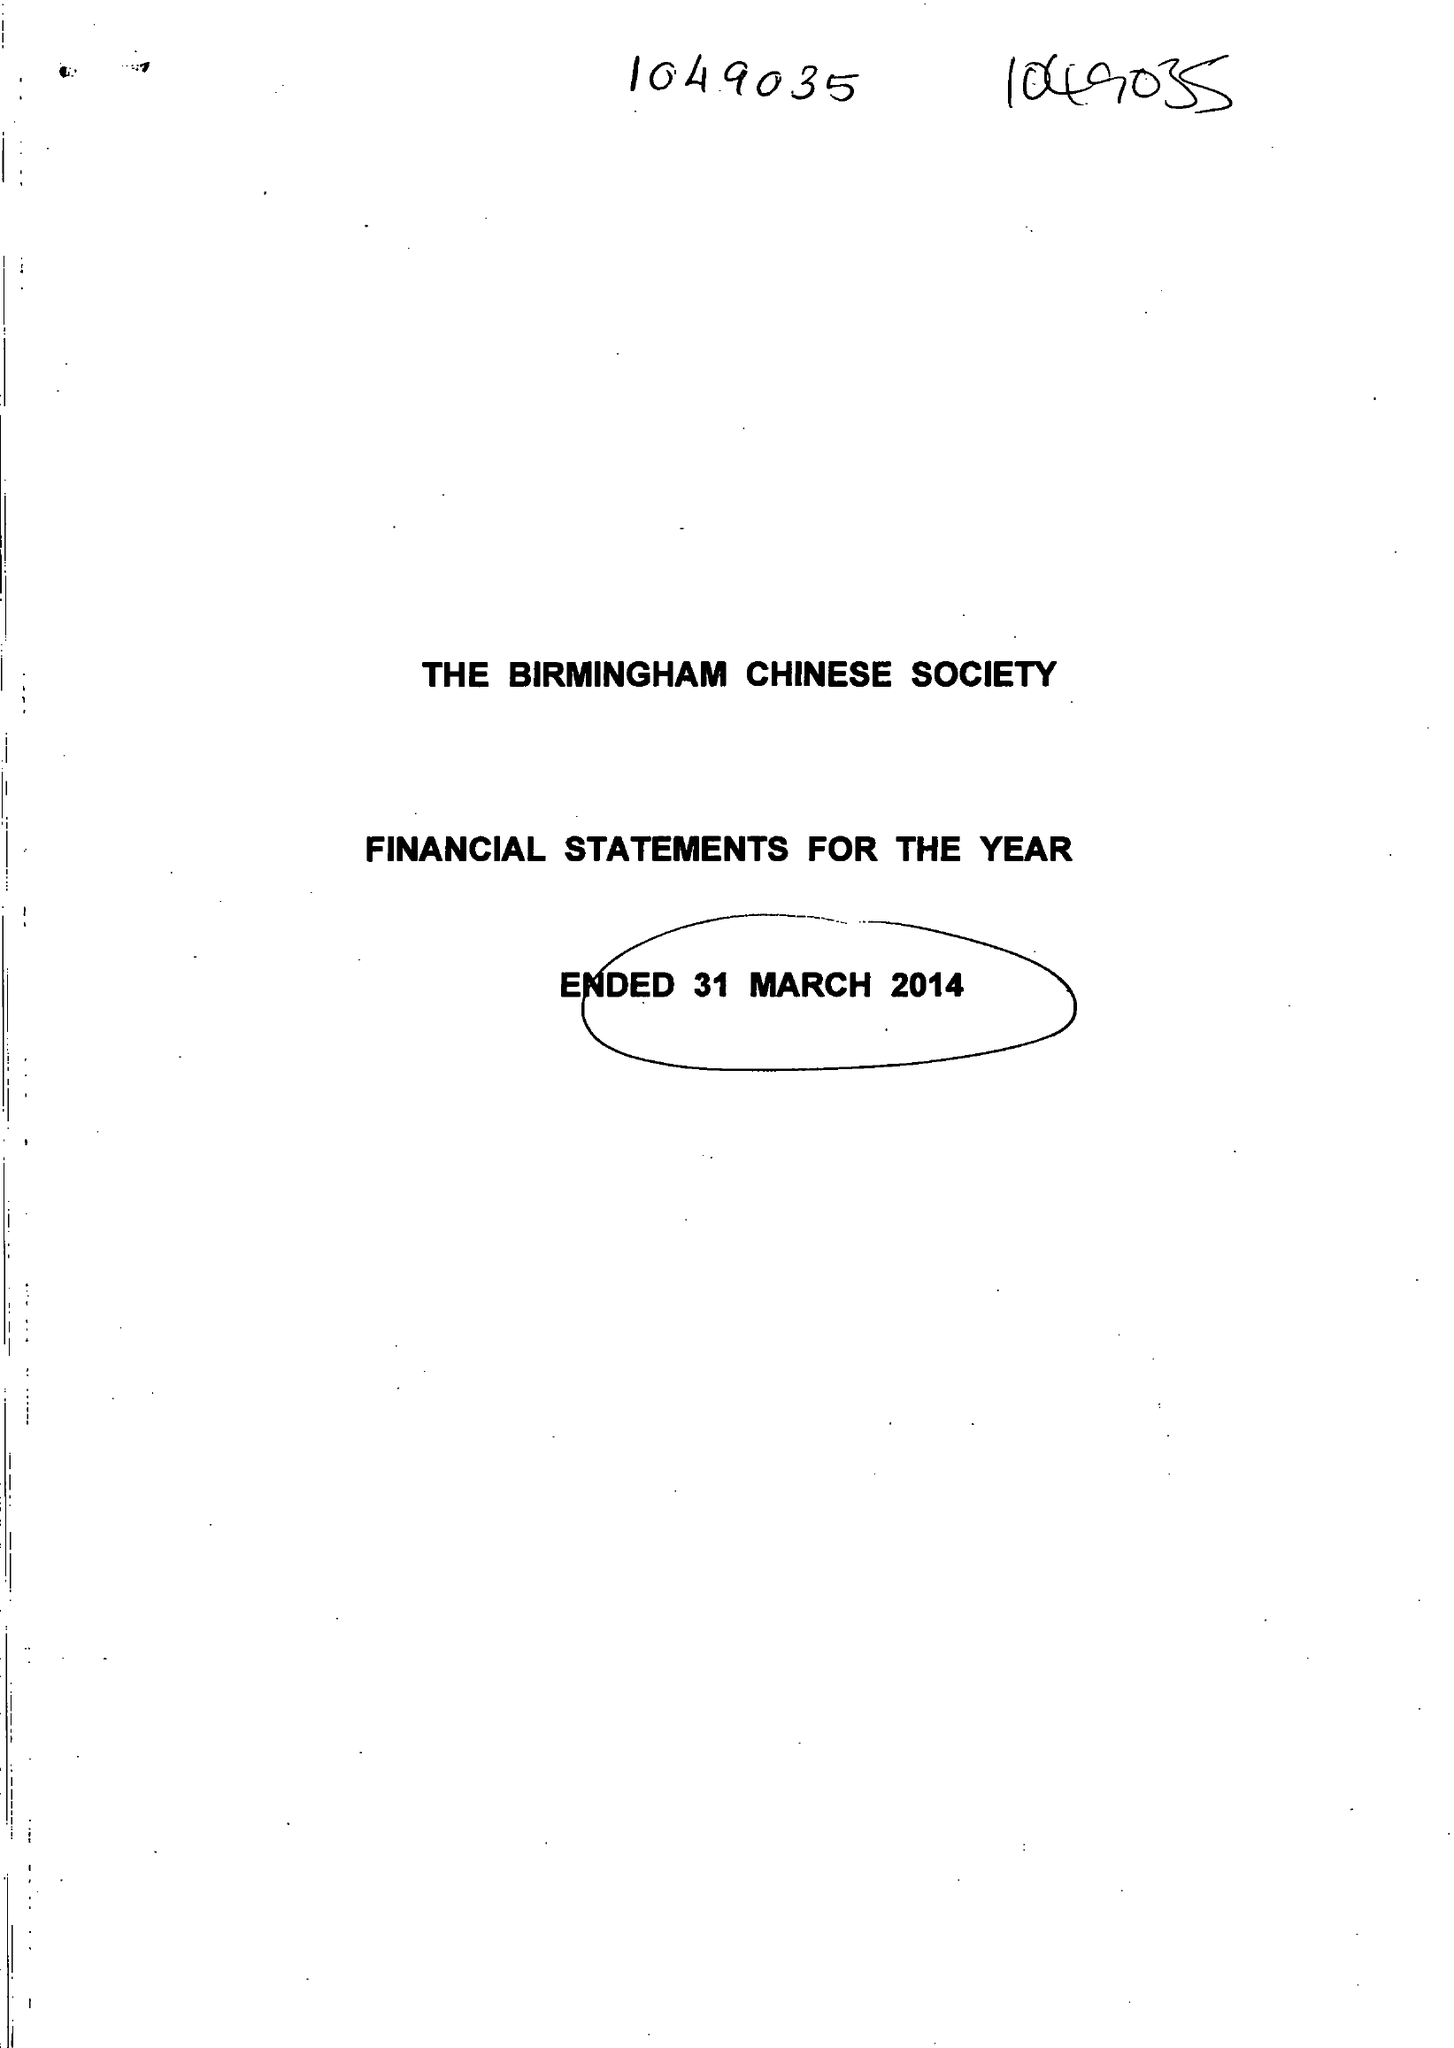What is the value for the report_date?
Answer the question using a single word or phrase. 2014-03-31 